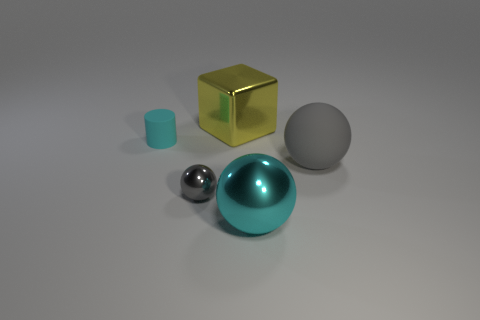Is the color of the big object that is to the right of the cyan metal sphere the same as the tiny thing that is in front of the small cyan cylinder?
Provide a short and direct response. Yes. What number of objects are in front of the matte thing that is behind the gray matte sphere?
Give a very brief answer. 3. Are there any small blue matte cubes?
Your response must be concise. No. How many other objects are there of the same color as the big cube?
Your answer should be compact. 0. Are there fewer big gray rubber things than small yellow matte cylinders?
Your answer should be very brief. No. There is a cyan thing to the right of the large metal thing behind the cylinder; what shape is it?
Ensure brevity in your answer.  Sphere. Are there any big metal things in front of the cyan cylinder?
Ensure brevity in your answer.  Yes. What is the color of the object that is the same size as the gray shiny sphere?
Offer a very short reply. Cyan. How many objects have the same material as the big yellow cube?
Offer a terse response. 2. How many other objects are there of the same size as the gray metal object?
Your answer should be compact. 1. 